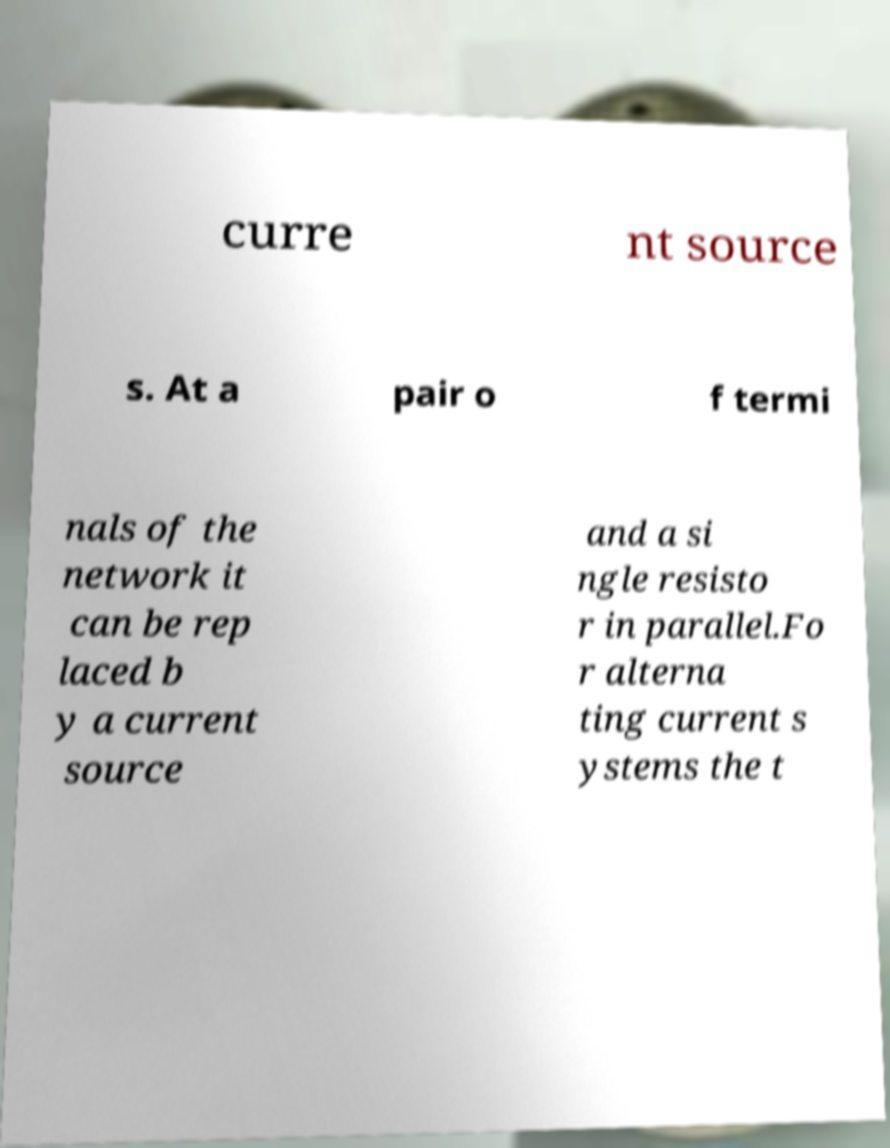There's text embedded in this image that I need extracted. Can you transcribe it verbatim? curre nt source s. At a pair o f termi nals of the network it can be rep laced b y a current source and a si ngle resisto r in parallel.Fo r alterna ting current s ystems the t 